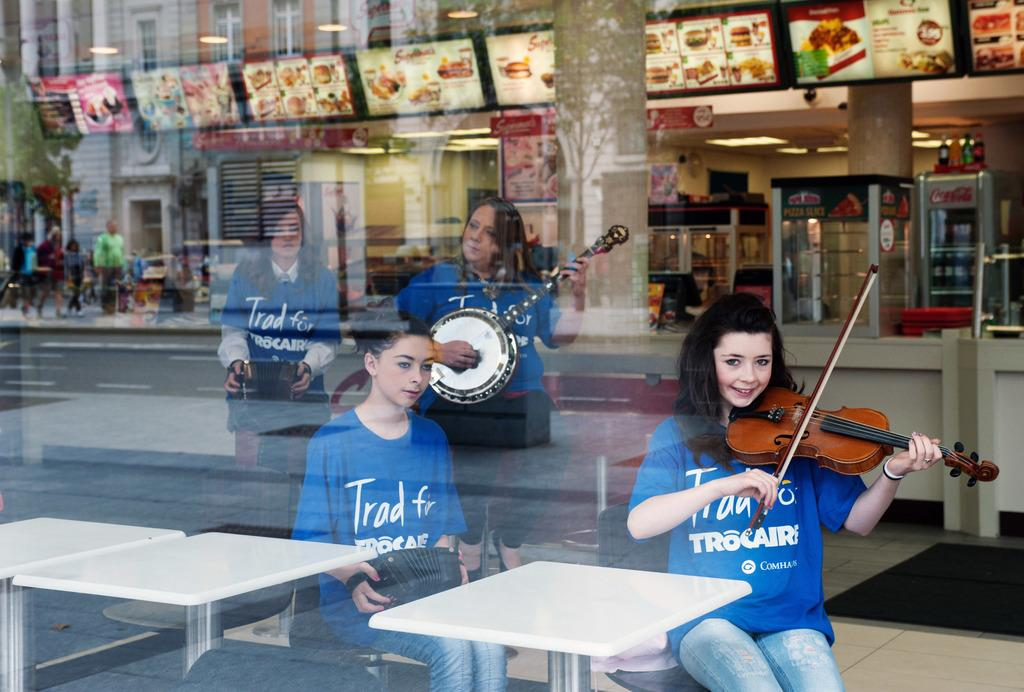Who is present in the image? There are women in the image. What are the women doing in the image? The women are sitting and playing a musical instrument. What can be seen in the background of the image? There are buildings, shops, and people standing on the footpath in the background of the image. How many eggs are being exchanged between the mice in the image? There are no mice or eggs present in the image. 